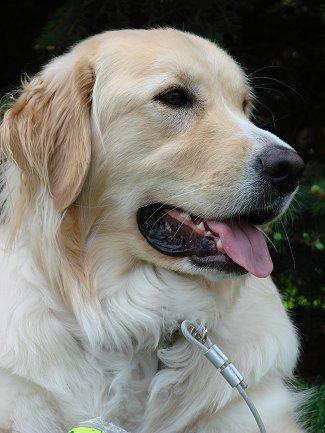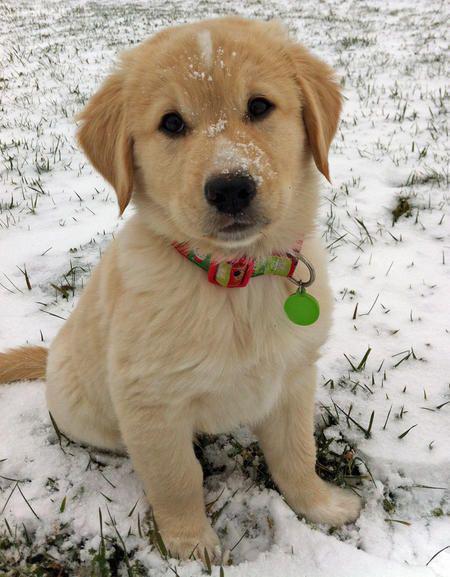The first image is the image on the left, the second image is the image on the right. Analyze the images presented: Is the assertion "In at least one of the images, the dog is inside." valid? Answer yes or no. No. 